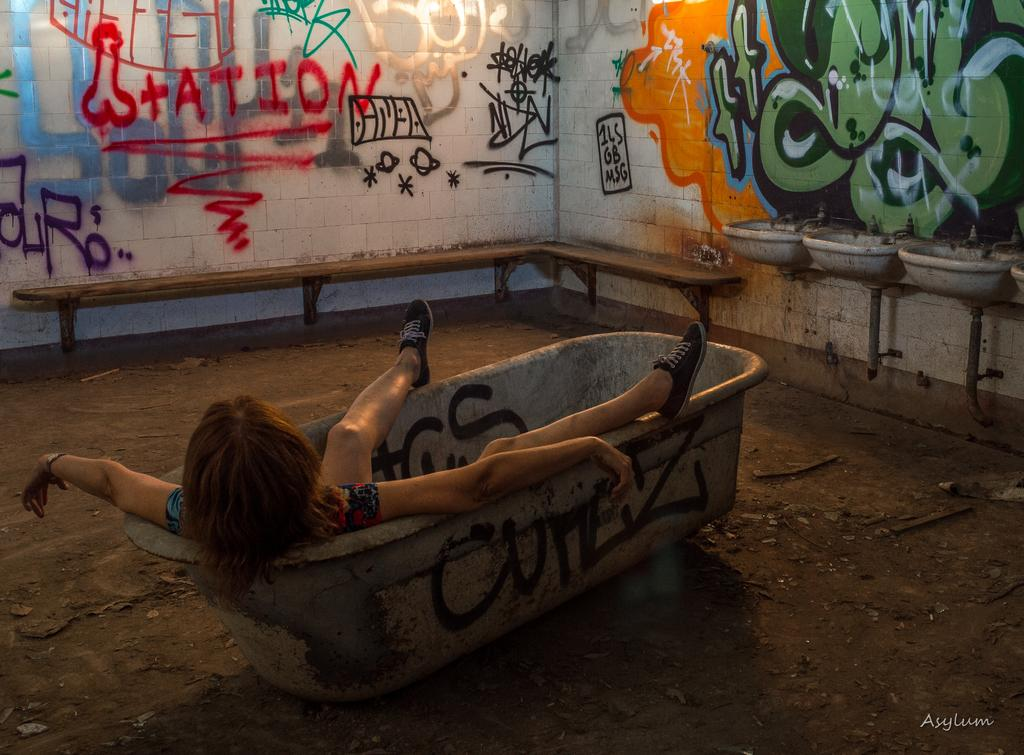What is the lady in the image doing? The lady is sitting in the tub in the image. What can be seen in the background of the image? There are sinks and a wall in the background of the image. What is on the wall in the background? Graffiti is present on the wall. What type of feast is being prepared on the side of the farm in the image? There is no feast or farm present in the image; it features a lady sitting in a tub with graffiti on the wall in the background. 